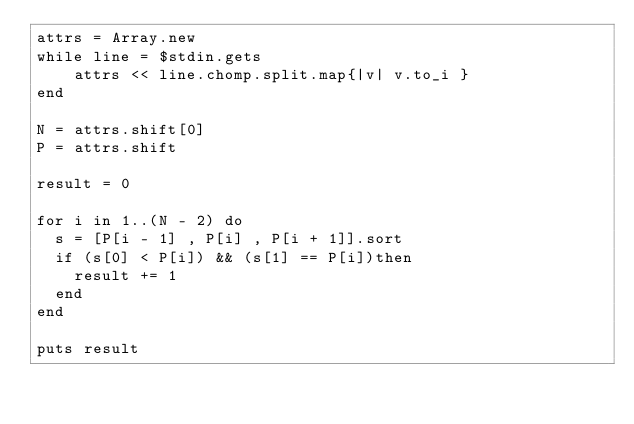Convert code to text. <code><loc_0><loc_0><loc_500><loc_500><_Ruby_>attrs = Array.new
while line = $stdin.gets
    attrs << line.chomp.split.map{|v| v.to_i }
end

N = attrs.shift[0]
P = attrs.shift

result = 0

for i in 1..(N - 2) do
  s = [P[i - 1] , P[i] , P[i + 1]].sort
  if (s[0] < P[i]) && (s[1] == P[i])then
    result += 1 
  end
end

puts result</code> 